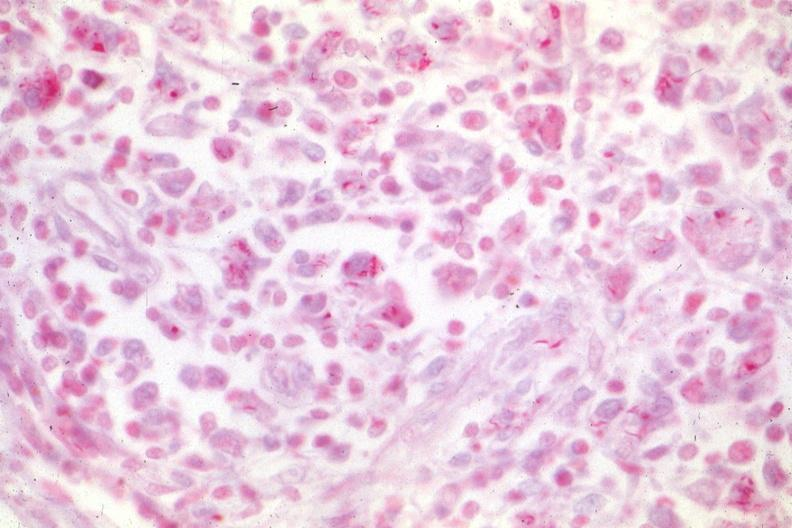what is present?
Answer the question using a single word or phrase. Mycobacterium avium intracellulare 